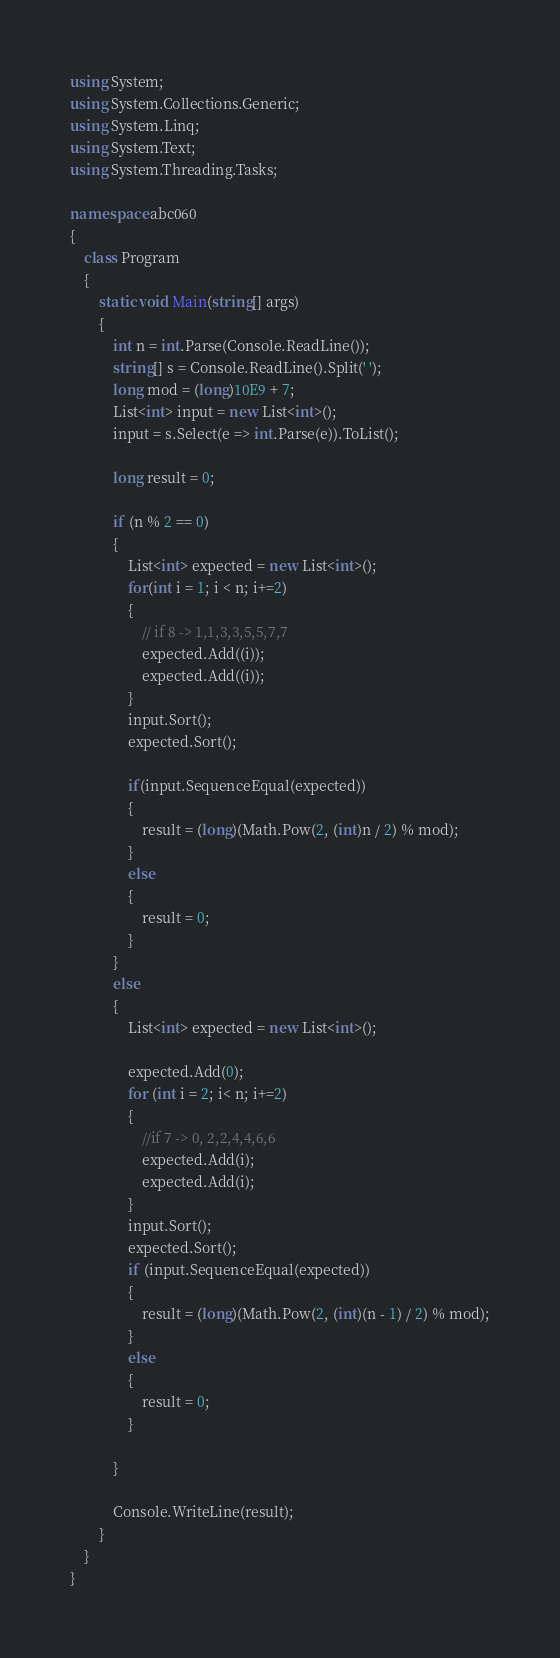<code> <loc_0><loc_0><loc_500><loc_500><_C#_>using System;
using System.Collections.Generic;
using System.Linq;
using System.Text;
using System.Threading.Tasks;

namespace abc060
{
    class Program
    {
        static void Main(string[] args)
        {
            int n = int.Parse(Console.ReadLine());
            string[] s = Console.ReadLine().Split(' ');
            long mod = (long)10E9 + 7;
            List<int> input = new List<int>();
            input = s.Select(e => int.Parse(e)).ToList();

            long result = 0;

            if (n % 2 == 0)
            {
                List<int> expected = new List<int>();
                for(int i = 1; i < n; i+=2)
                {
                    // if 8 -> 1,1,3,3,5,5,7,7
                    expected.Add((i));
                    expected.Add((i));
                }
                input.Sort();
                expected.Sort();

                if(input.SequenceEqual(expected))
                {
                    result = (long)(Math.Pow(2, (int)n / 2) % mod);
                }
                else
                {
                    result = 0;
                }
            }
            else
            {
                List<int> expected = new List<int>();

                expected.Add(0);
                for (int i = 2; i< n; i+=2)
                {
                    //if 7 -> 0, 2,2,4,4,6,6
                    expected.Add(i);
                    expected.Add(i);
                }
                input.Sort();
                expected.Sort();
                if (input.SequenceEqual(expected))
                {
                    result = (long)(Math.Pow(2, (int)(n - 1) / 2) % mod);
                }
                else
                {
                    result = 0;
                }

            }

            Console.WriteLine(result);
        }
    }
}
</code> 